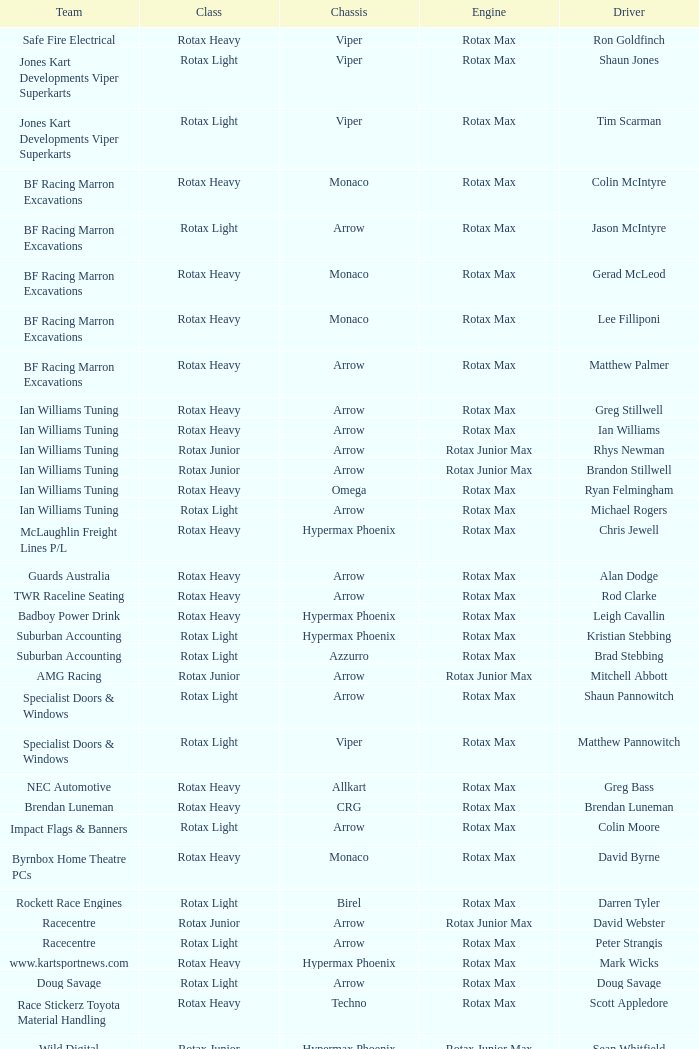What kind of motor does the bf racing marron excavations possess with monaco as the frame and lee filliponi as the pilot? Rotax Max. 